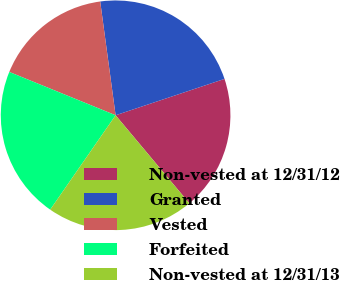<chart> <loc_0><loc_0><loc_500><loc_500><pie_chart><fcel>Non-vested at 12/31/12<fcel>Granted<fcel>Vested<fcel>Forfeited<fcel>Non-vested at 12/31/13<nl><fcel>19.03%<fcel>22.01%<fcel>16.7%<fcel>21.51%<fcel>20.74%<nl></chart> 